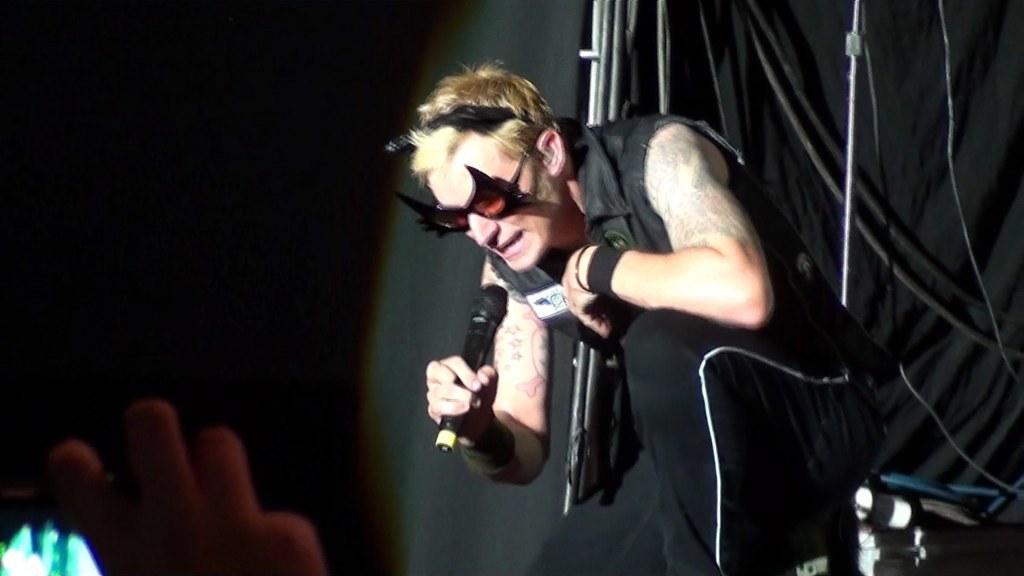What is the person in the image holding? The person is holding a mic in the image. What can be seen in the background of the image? There are rods and a black color curtain in the background of the image. Can you describe the hand visible on the left side of the image? A person's hand is visible on the left side of the image. What type of stem is being used to make the payment in the image? There is no stem or payment being made in the image; it features a person holding a mic with rods and a black curtain in the background. 